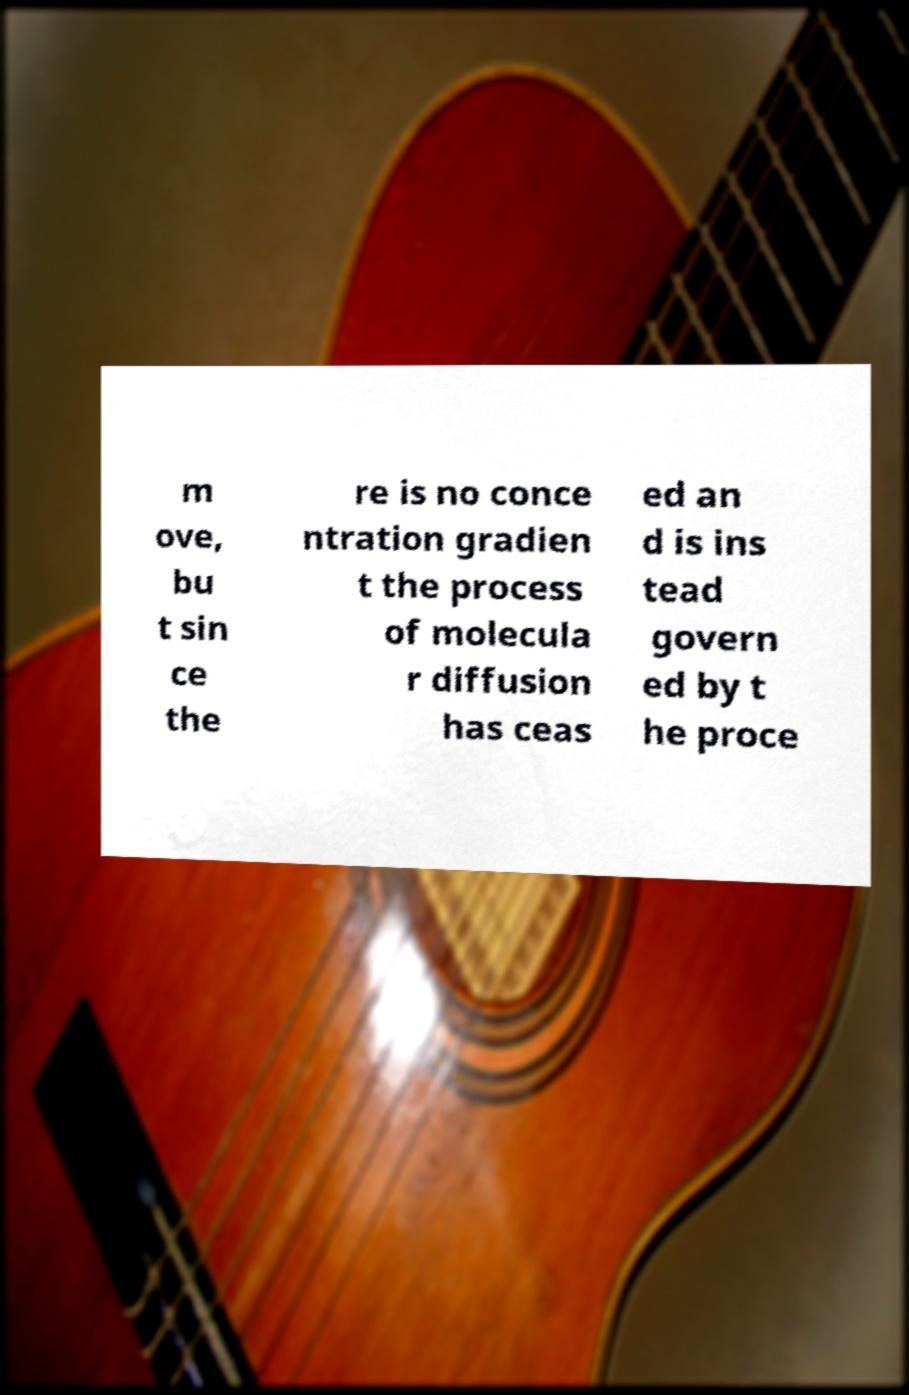Could you extract and type out the text from this image? m ove, bu t sin ce the re is no conce ntration gradien t the process of molecula r diffusion has ceas ed an d is ins tead govern ed by t he proce 